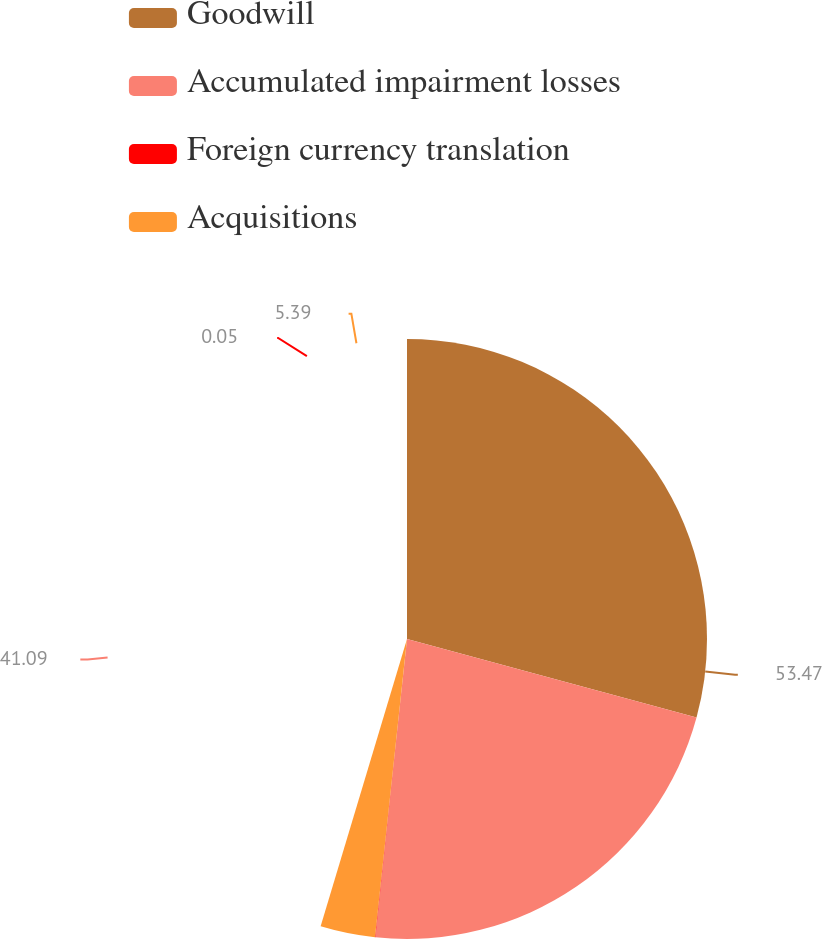<chart> <loc_0><loc_0><loc_500><loc_500><pie_chart><fcel>Goodwill<fcel>Accumulated impairment losses<fcel>Foreign currency translation<fcel>Acquisitions<nl><fcel>53.46%<fcel>41.09%<fcel>0.05%<fcel>5.39%<nl></chart> 